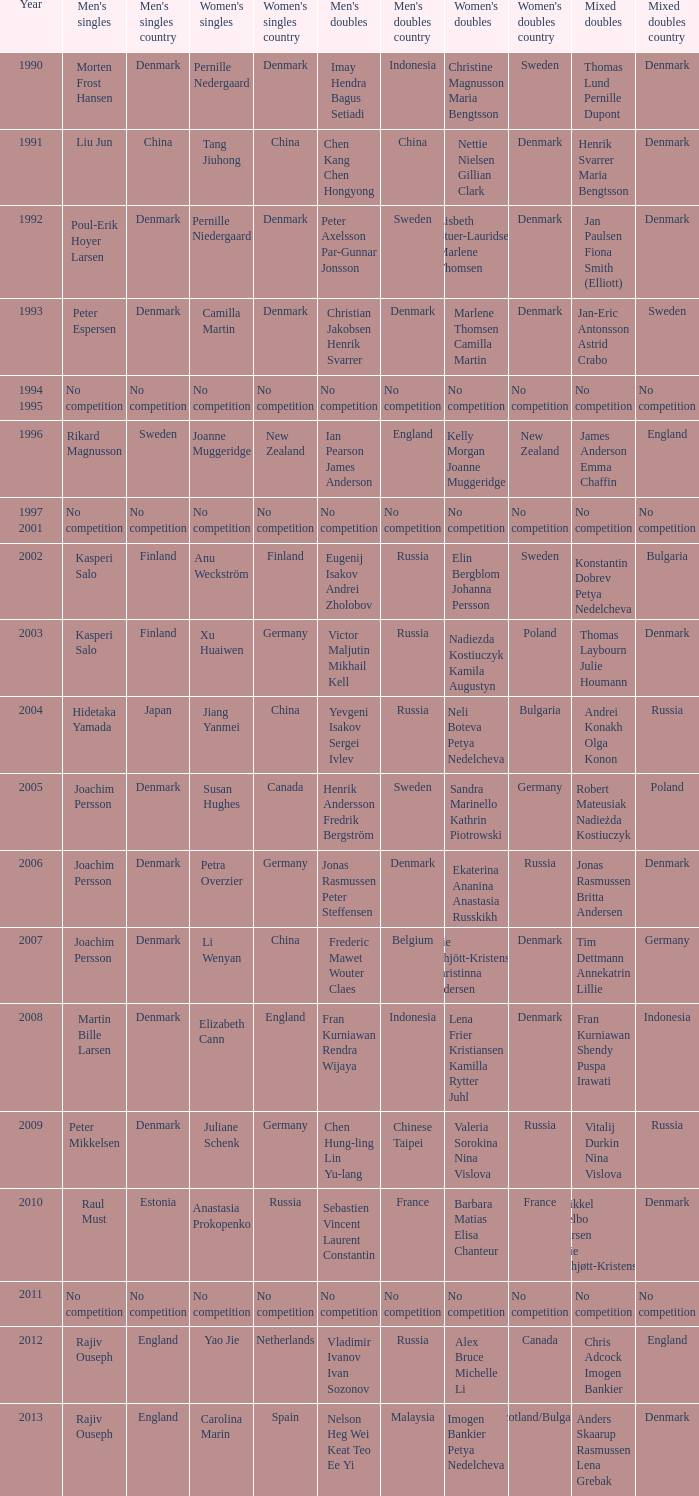What year did Carolina Marin win the Women's singles? 2013.0. 